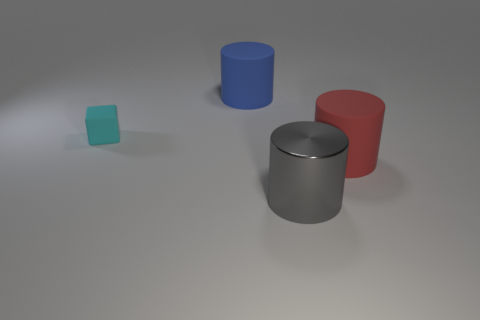Is there any other thing that has the same size as the cyan object?
Give a very brief answer. No. There is a rubber cylinder that is on the left side of the metal cylinder; does it have the same size as the tiny block?
Ensure brevity in your answer.  No. What color is the object that is right of the tiny rubber object and behind the big red matte thing?
Provide a succinct answer. Blue. Are there more cylinders that are on the left side of the large red rubber thing than big purple matte blocks?
Ensure brevity in your answer.  Yes. Are there any cyan metallic cylinders?
Ensure brevity in your answer.  No. Is the tiny rubber block the same color as the big shiny object?
Your answer should be very brief. No. What number of large objects are red objects or cylinders?
Provide a short and direct response. 3. Is there any other thing of the same color as the tiny rubber cube?
Provide a succinct answer. No. There is a big blue object that is the same material as the tiny cyan object; what is its shape?
Provide a short and direct response. Cylinder. There is a matte cylinder that is to the left of the gray shiny cylinder; what size is it?
Your answer should be very brief. Large. 